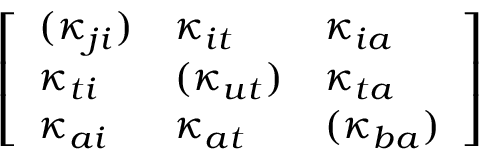<formula> <loc_0><loc_0><loc_500><loc_500>\left [ \begin{array} { l l l } { ( \kappa _ { j i } ) } & { \kappa _ { i t } } & { \kappa _ { i a } } \\ { \kappa _ { t i } } & { ( \kappa _ { u t } ) } & { \kappa _ { t a } } \\ { \kappa _ { a i } } & { \kappa _ { a t } } & { ( \kappa _ { b a } ) } \end{array} \right ]</formula> 